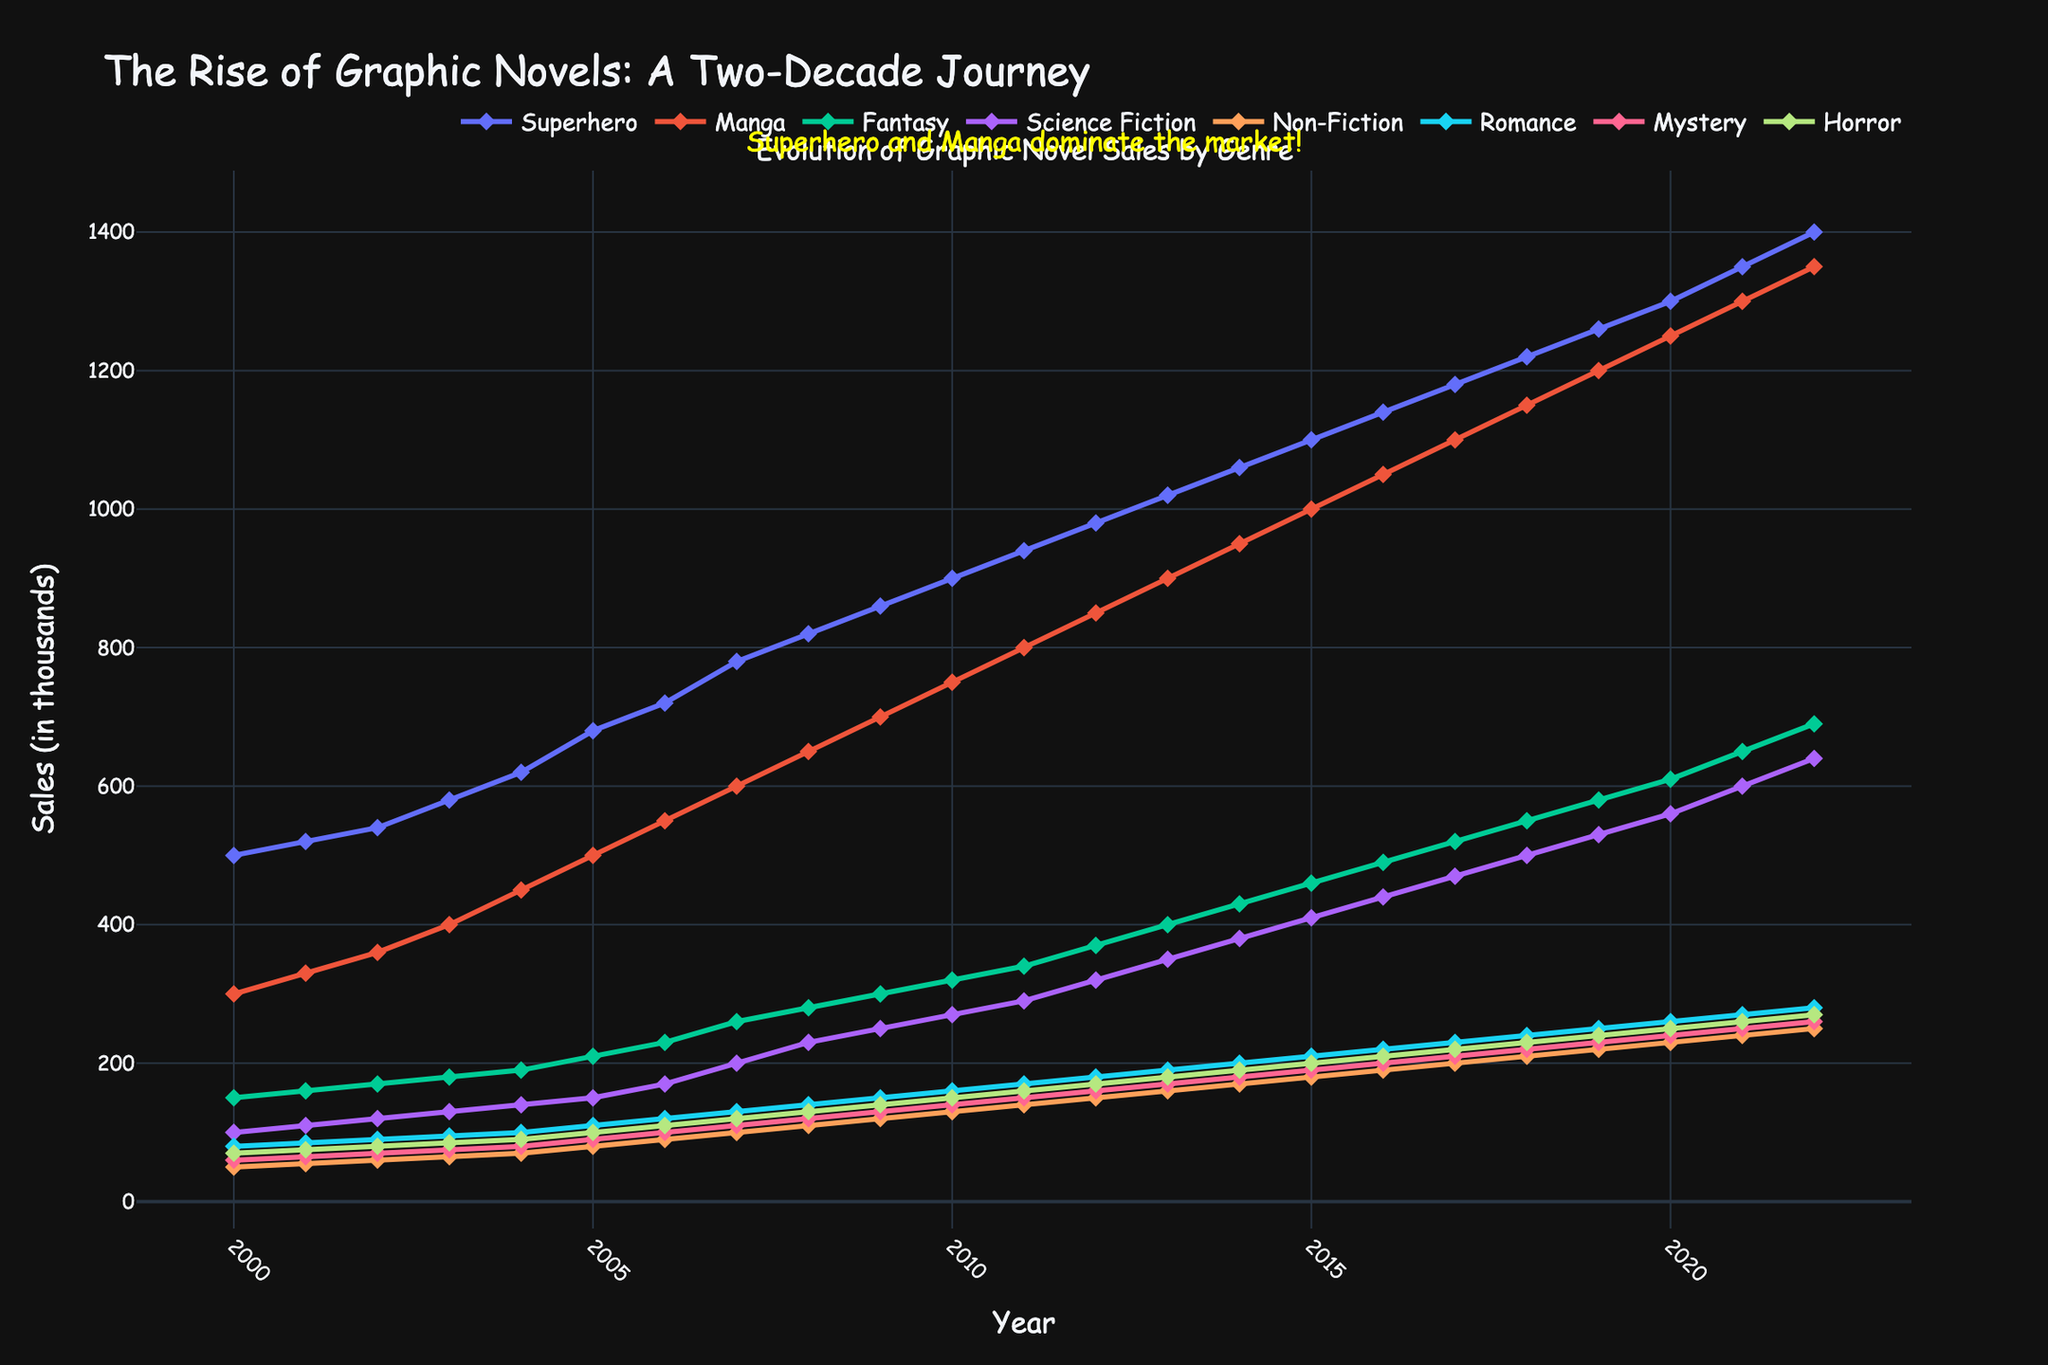What is the title of the figure? The title is located at the top of the figure. In this case, the title reads "The Rise of Graphic Novels: A Two-Decade Journey."
Answer: The Rise of Graphic Novels: A Two-Decade Journey How many genres are tracked in the figure? The genres are indicated by the legend and individual lines on the plot. There are eight lines, each representing a different genre.
Answer: Eight Which genre had the highest sales in 2022? By looking at the lines at the rightmost part of the graph for the year 2022, the line for "Superhero" is clearly the highest.
Answer: Superhero Which genre saw the smallest growth in sales from 2000 to 2022? To find this, subtract the sales figure in 2000 from the sales figure in 2022 for each genre. The genre with the smallest difference is "Non-Fiction."
Answer: Non-Fiction What was the sales figure for Manga in 2010? Locate the data point for Manga on the line corresponding to the year 2010. The sales figure for Manga is 750.
Answer: 750 Did any genre experience a sales decline at any point? Following each line from left to right, none of the lines dip downwards or show a decline in sales at any year, indicating no genre experienced a decline.
Answer: No What is the biggest difference in sales between any two genres in 2015? Note the sales figures for all genres in 2015 and find the largest difference. Superhero had 1100 and Non-Fiction had 180, making the difference 920 (1100 - 180).
Answer: 920 Which genres have a sales figure exceeding 1000 in 2018? Check the values at 2018; "Superhero," "Manga," and "Fantasy" exceed 1000 in sales.
Answer: Superhero, Manga, Fantasy Which genre had the most sales increase after 2010 until 2022? Calculate the sales increase for each genre from 2010 to 2022. The difference for each genre: Superhero: 500, Manga: 550, Fantasy: 330, Science Fiction: 370, Non-Fiction: 120, Romance: 120, Mystery: 110, Horror: 120. Manga had the largest increase, 550.
Answer: Manga What does the annotation on the figure indicate? Find the text annotation on the figure. It mentions that "Superhero and Manga dominate the market!" indicating these two genres have the highest sales.
Answer: Superhero and Manga dominate the market! 